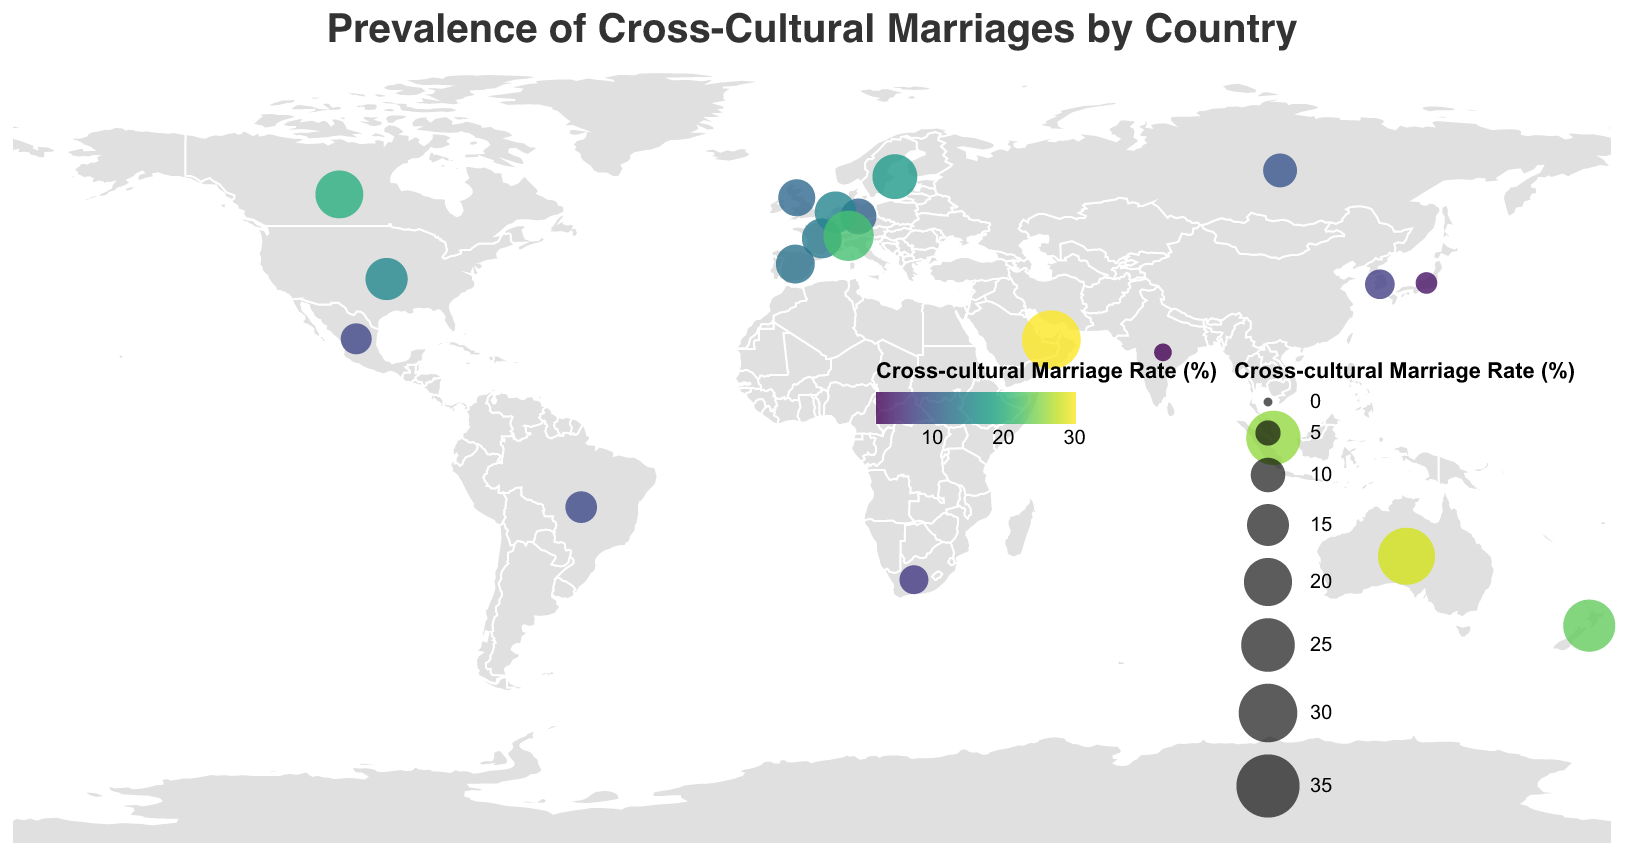Which country has the highest cross-cultural marriage rate? The figure visually shows the United Arab Emirates with the largest circle, indicating the highest cross-cultural marriage rate.
Answer: United Arab Emirates Which two countries have cross-cultural marriage rates above 25%? The figure indicates that Australia and Singapore both have cross-cultural marriage rates above 25%, as shown by the large circles colored in the higher range of the color scale.
Answer: Australia, Singapore What is the difference in the cross-cultural marriage rates between the United States and Germany? The cross-cultural marriage rate for the United States is 15.2% and for Germany is 10.9%. The difference is 15.2 - 10.9.
Answer: 4.3% Which region has generally lower cross-cultural marriage rates: Asia or Europe? By observing the locations on the map, most Asian countries (Japan, South Korea, India) have lower cross-cultural marriage rates compared to European countries like France, Germany, and the UK.
Answer: Asia Which country in South America has data shown in the figure, and what is its cross-cultural marriage rate? The figure shows a circle in Brazil indicating its cross-cultural marriage rate of 8.3%.
Answer: Brazil, 8.3% What color represents the highest cross-cultural marriage rates? The figure uses the color scheme 'viridis'. The highest values are represented by colors closer to yellow.
Answer: Yellow How many countries in the figure have a cross-cultural marriage rate below 10%? Observing the size and color of circles, countries with rates below 10% are Brazil, Japan, South Korea, India, Russia, and South Africa.
Answer: 6 What's the average cross-cultural marriage rate for the countries displayed in the figure? The sum of the cross-cultural marriage rates is (15.2 + 19.8 + 11.6 + 13.5 + 10.9 + 28.4 + 25.7 + 8.3 + 3.5 + 7.2 + 2.1 + 9.6 + 17.3 + 12.8 + 14.7 + 21.9 + 23.6 + 30.2 + 6.8 + 7.9) which equals 321.4. There are 20 countries, so the average is 321.4 / 20.
Answer: 16.07% Which country in the Southern Hemisphere has the highest rate of cross-cultural marriage? In the Southern Hemisphere, the countries shown are Australia, Brazil, New Zealand, South Africa, and the United Arab Emirates. Among these, the United Arab Emirates has the highest rate at 30.2%.
Answer: United Arab Emirates Which country has a cross-cultural marriage rate closest to 20%? Observing the circle sizes and colors near the 20% mark, Canada has a rate of 19.8%, closest to 20%.
Answer: Canada 